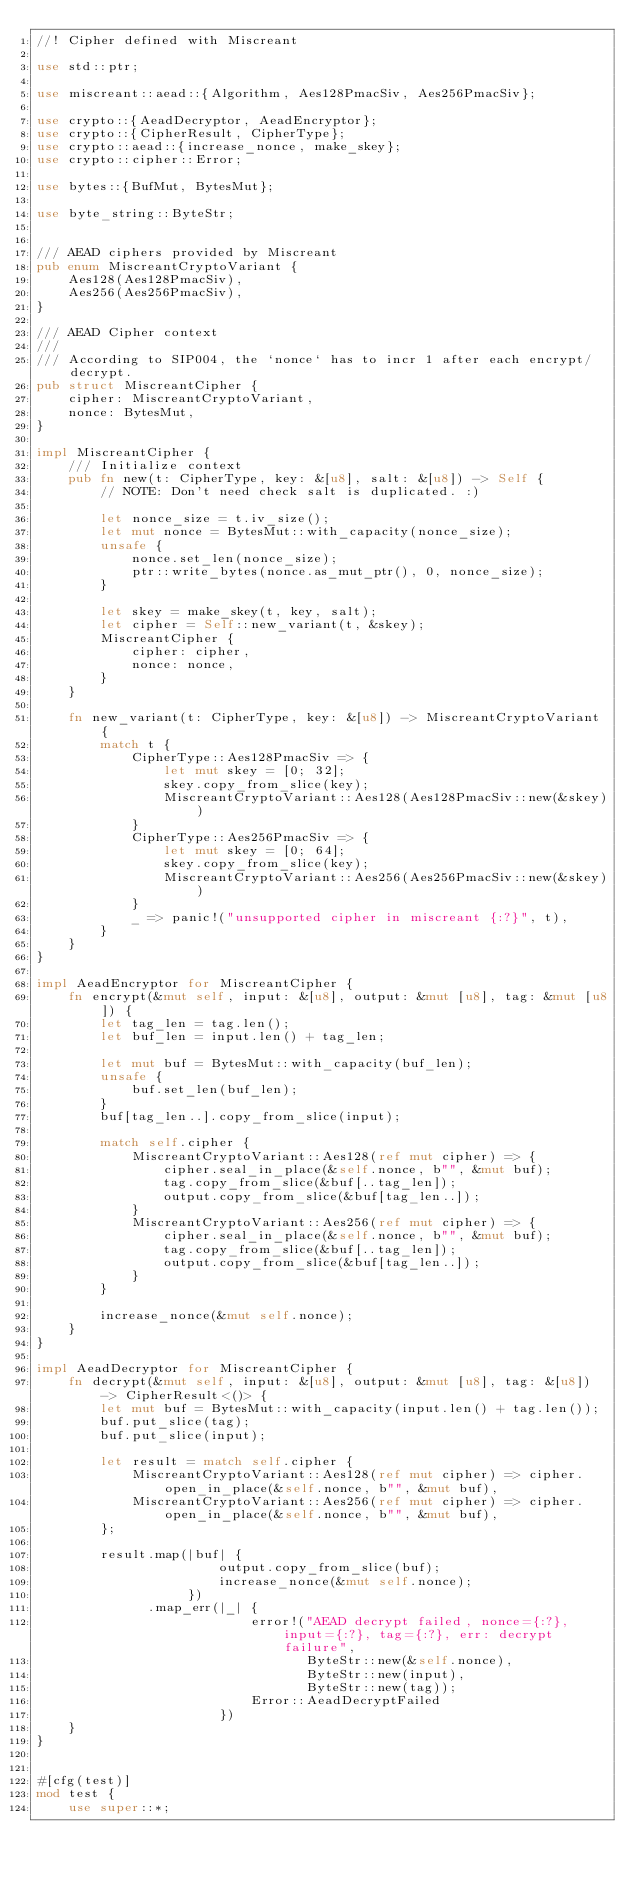<code> <loc_0><loc_0><loc_500><loc_500><_Rust_>//! Cipher defined with Miscreant

use std::ptr;

use miscreant::aead::{Algorithm, Aes128PmacSiv, Aes256PmacSiv};

use crypto::{AeadDecryptor, AeadEncryptor};
use crypto::{CipherResult, CipherType};
use crypto::aead::{increase_nonce, make_skey};
use crypto::cipher::Error;

use bytes::{BufMut, BytesMut};

use byte_string::ByteStr;


/// AEAD ciphers provided by Miscreant
pub enum MiscreantCryptoVariant {
    Aes128(Aes128PmacSiv),
    Aes256(Aes256PmacSiv),
}

/// AEAD Cipher context
///
/// According to SIP004, the `nonce` has to incr 1 after each encrypt/decrypt.
pub struct MiscreantCipher {
    cipher: MiscreantCryptoVariant,
    nonce: BytesMut,
}

impl MiscreantCipher {
    /// Initialize context
    pub fn new(t: CipherType, key: &[u8], salt: &[u8]) -> Self {
        // NOTE: Don't need check salt is duplicated. :)

        let nonce_size = t.iv_size();
        let mut nonce = BytesMut::with_capacity(nonce_size);
        unsafe {
            nonce.set_len(nonce_size);
            ptr::write_bytes(nonce.as_mut_ptr(), 0, nonce_size);
        }

        let skey = make_skey(t, key, salt);
        let cipher = Self::new_variant(t, &skey);
        MiscreantCipher {
            cipher: cipher,
            nonce: nonce,
        }
    }

    fn new_variant(t: CipherType, key: &[u8]) -> MiscreantCryptoVariant {
        match t {
            CipherType::Aes128PmacSiv => {
                let mut skey = [0; 32];
                skey.copy_from_slice(key);
                MiscreantCryptoVariant::Aes128(Aes128PmacSiv::new(&skey))
            }
            CipherType::Aes256PmacSiv => {
                let mut skey = [0; 64];
                skey.copy_from_slice(key);
                MiscreantCryptoVariant::Aes256(Aes256PmacSiv::new(&skey))
            }
            _ => panic!("unsupported cipher in miscreant {:?}", t),
        }
    }
}

impl AeadEncryptor for MiscreantCipher {
    fn encrypt(&mut self, input: &[u8], output: &mut [u8], tag: &mut [u8]) {
        let tag_len = tag.len();
        let buf_len = input.len() + tag_len;

        let mut buf = BytesMut::with_capacity(buf_len);
        unsafe {
            buf.set_len(buf_len);
        }
        buf[tag_len..].copy_from_slice(input);

        match self.cipher {
            MiscreantCryptoVariant::Aes128(ref mut cipher) => {
                cipher.seal_in_place(&self.nonce, b"", &mut buf);
                tag.copy_from_slice(&buf[..tag_len]);
                output.copy_from_slice(&buf[tag_len..]);
            }
            MiscreantCryptoVariant::Aes256(ref mut cipher) => {
                cipher.seal_in_place(&self.nonce, b"", &mut buf);
                tag.copy_from_slice(&buf[..tag_len]);
                output.copy_from_slice(&buf[tag_len..]);
            }
        }

        increase_nonce(&mut self.nonce);
    }
}

impl AeadDecryptor for MiscreantCipher {
    fn decrypt(&mut self, input: &[u8], output: &mut [u8], tag: &[u8]) -> CipherResult<()> {
        let mut buf = BytesMut::with_capacity(input.len() + tag.len());
        buf.put_slice(tag);
        buf.put_slice(input);

        let result = match self.cipher {
            MiscreantCryptoVariant::Aes128(ref mut cipher) => cipher.open_in_place(&self.nonce, b"", &mut buf),
            MiscreantCryptoVariant::Aes256(ref mut cipher) => cipher.open_in_place(&self.nonce, b"", &mut buf),
        };

        result.map(|buf| {
                       output.copy_from_slice(buf);
                       increase_nonce(&mut self.nonce);
                   })
              .map_err(|_| {
                           error!("AEAD decrypt failed, nonce={:?}, input={:?}, tag={:?}, err: decrypt failure",
                                  ByteStr::new(&self.nonce),
                                  ByteStr::new(input),
                                  ByteStr::new(tag));
                           Error::AeadDecryptFailed
                       })
    }
}


#[cfg(test)]
mod test {
    use super::*;</code> 